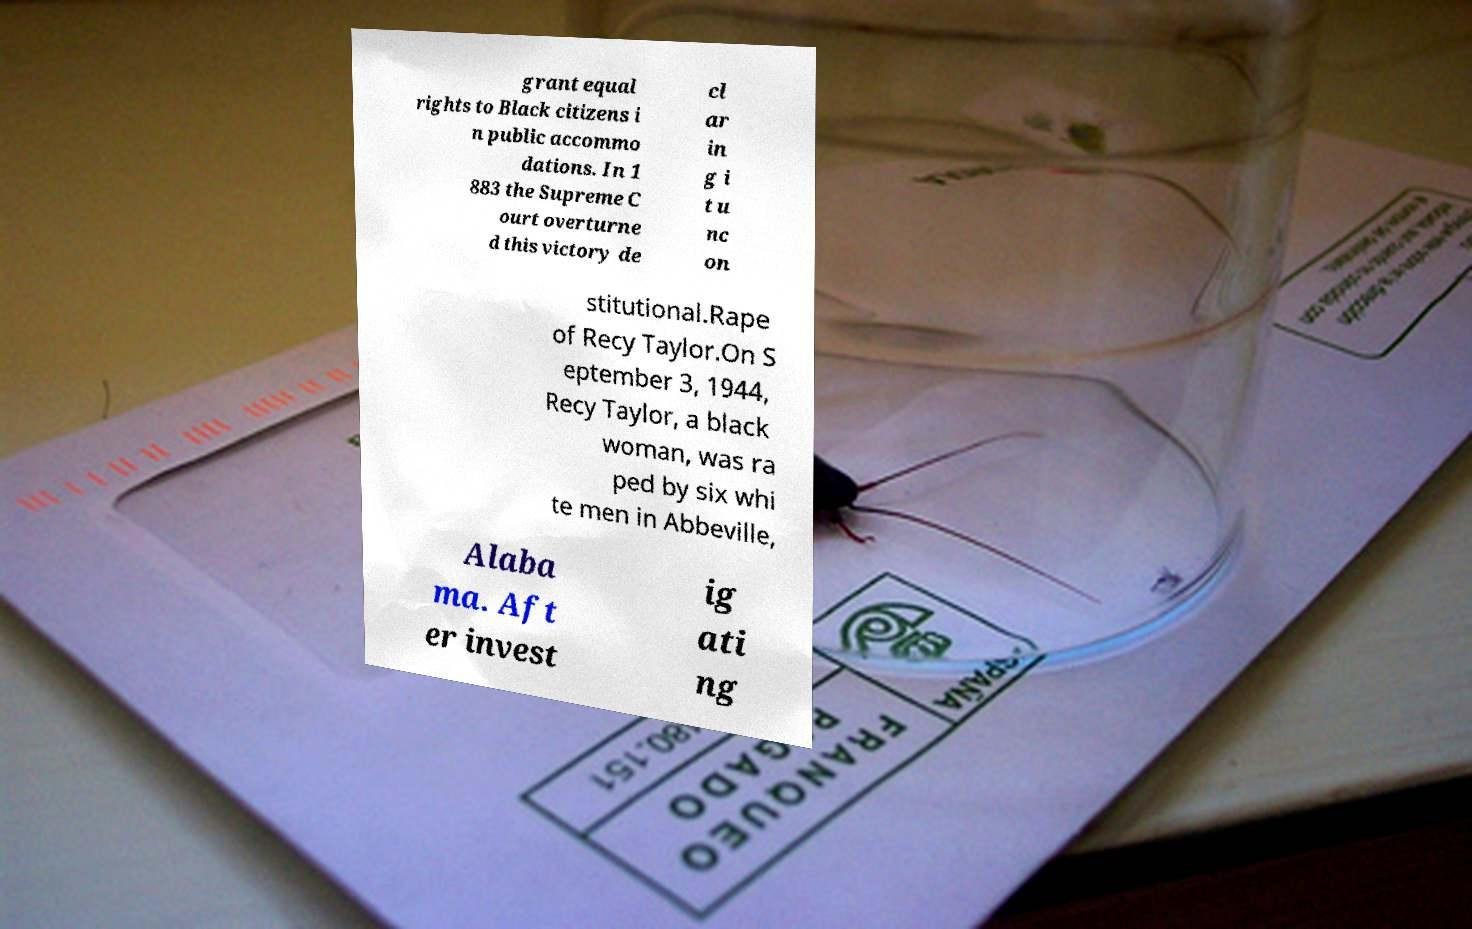I need the written content from this picture converted into text. Can you do that? grant equal rights to Black citizens i n public accommo dations. In 1 883 the Supreme C ourt overturne d this victory de cl ar in g i t u nc on stitutional.Rape of Recy Taylor.On S eptember 3, 1944, Recy Taylor, a black woman, was ra ped by six whi te men in Abbeville, Alaba ma. Aft er invest ig ati ng 